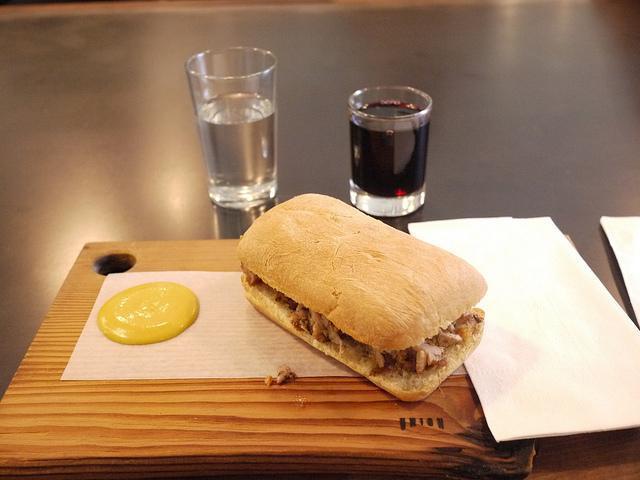Is this affirmation: "The sandwich is in the middle of the dining table." correct?
Answer yes or no. No. 